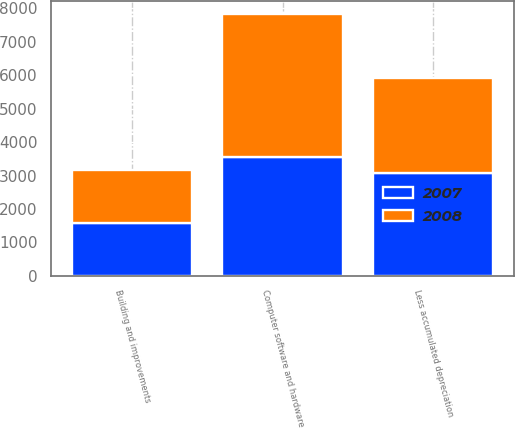Convert chart to OTSL. <chart><loc_0><loc_0><loc_500><loc_500><stacked_bar_chart><ecel><fcel>Building and improvements<fcel>Computer software and hardware<fcel>Less accumulated depreciation<nl><fcel>2007<fcel>1581<fcel>3553<fcel>3068<nl><fcel>2008<fcel>1581<fcel>4275<fcel>2860<nl></chart> 